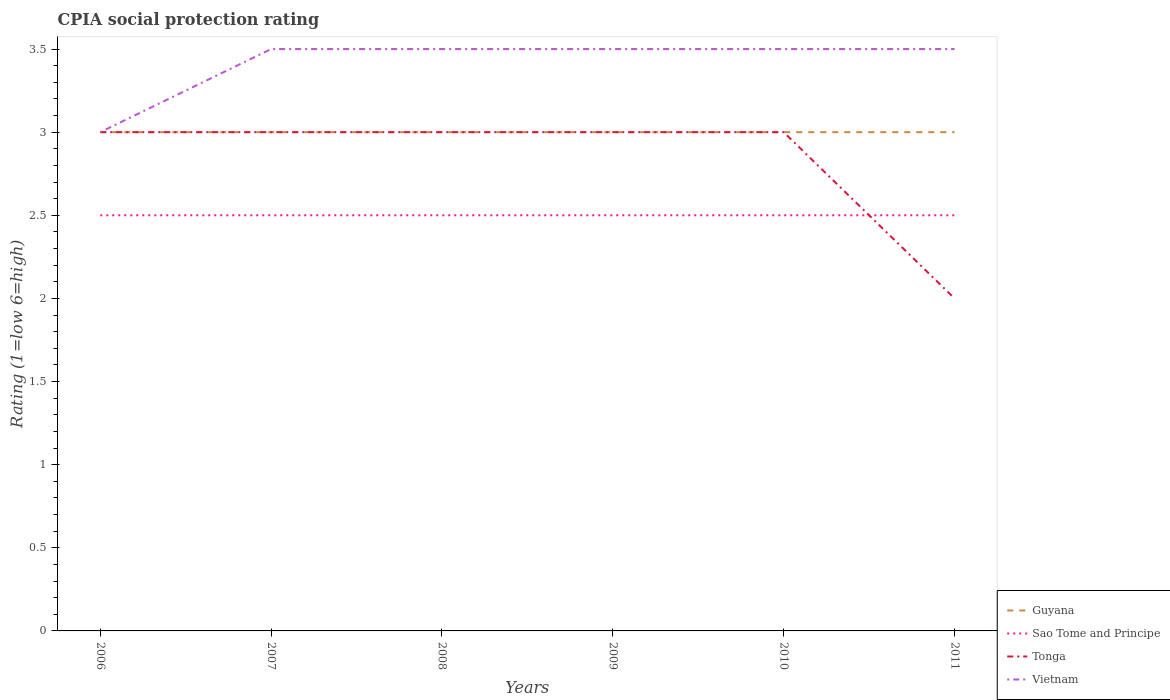Is the number of lines equal to the number of legend labels?
Your response must be concise. Yes. What is the total CPIA rating in Sao Tome and Principe in the graph?
Make the answer very short. 0. What is the difference between the highest and the lowest CPIA rating in Vietnam?
Your answer should be compact. 5. How many years are there in the graph?
Provide a succinct answer. 6. What is the difference between two consecutive major ticks on the Y-axis?
Your response must be concise. 0.5. Are the values on the major ticks of Y-axis written in scientific E-notation?
Ensure brevity in your answer.  No. Does the graph contain any zero values?
Offer a very short reply. No. How many legend labels are there?
Your answer should be compact. 4. How are the legend labels stacked?
Give a very brief answer. Vertical. What is the title of the graph?
Keep it short and to the point. CPIA social protection rating. Does "Mongolia" appear as one of the legend labels in the graph?
Make the answer very short. No. What is the label or title of the X-axis?
Your answer should be compact. Years. What is the label or title of the Y-axis?
Your answer should be very brief. Rating (1=low 6=high). What is the Rating (1=low 6=high) of Guyana in 2006?
Your answer should be very brief. 3. What is the Rating (1=low 6=high) in Tonga in 2006?
Make the answer very short. 3. What is the Rating (1=low 6=high) of Vietnam in 2006?
Provide a succinct answer. 3. What is the Rating (1=low 6=high) of Guyana in 2007?
Offer a terse response. 3. What is the Rating (1=low 6=high) of Guyana in 2008?
Provide a short and direct response. 3. What is the Rating (1=low 6=high) in Sao Tome and Principe in 2008?
Offer a terse response. 2.5. What is the Rating (1=low 6=high) in Tonga in 2008?
Your answer should be very brief. 3. What is the Rating (1=low 6=high) of Vietnam in 2008?
Provide a succinct answer. 3.5. What is the Rating (1=low 6=high) in Guyana in 2009?
Ensure brevity in your answer.  3. What is the Rating (1=low 6=high) of Tonga in 2009?
Make the answer very short. 3. What is the Rating (1=low 6=high) of Vietnam in 2009?
Your answer should be very brief. 3.5. What is the Rating (1=low 6=high) in Sao Tome and Principe in 2010?
Offer a very short reply. 2.5. What is the Rating (1=low 6=high) of Vietnam in 2010?
Your response must be concise. 3.5. What is the Rating (1=low 6=high) in Guyana in 2011?
Your answer should be compact. 3. What is the Rating (1=low 6=high) of Tonga in 2011?
Offer a terse response. 2. What is the Rating (1=low 6=high) of Vietnam in 2011?
Ensure brevity in your answer.  3.5. Across all years, what is the maximum Rating (1=low 6=high) in Guyana?
Your response must be concise. 3. Across all years, what is the maximum Rating (1=low 6=high) in Vietnam?
Your response must be concise. 3.5. Across all years, what is the minimum Rating (1=low 6=high) of Sao Tome and Principe?
Your answer should be very brief. 2.5. Across all years, what is the minimum Rating (1=low 6=high) in Tonga?
Give a very brief answer. 2. What is the total Rating (1=low 6=high) in Sao Tome and Principe in the graph?
Provide a succinct answer. 15. What is the total Rating (1=low 6=high) in Tonga in the graph?
Your answer should be compact. 17. What is the total Rating (1=low 6=high) of Vietnam in the graph?
Give a very brief answer. 20.5. What is the difference between the Rating (1=low 6=high) in Tonga in 2006 and that in 2007?
Your answer should be very brief. 0. What is the difference between the Rating (1=low 6=high) of Tonga in 2006 and that in 2008?
Your answer should be compact. 0. What is the difference between the Rating (1=low 6=high) of Vietnam in 2006 and that in 2008?
Your response must be concise. -0.5. What is the difference between the Rating (1=low 6=high) of Guyana in 2006 and that in 2009?
Provide a short and direct response. 0. What is the difference between the Rating (1=low 6=high) of Tonga in 2006 and that in 2009?
Your answer should be compact. 0. What is the difference between the Rating (1=low 6=high) in Vietnam in 2006 and that in 2009?
Provide a succinct answer. -0.5. What is the difference between the Rating (1=low 6=high) in Guyana in 2006 and that in 2010?
Offer a very short reply. 0. What is the difference between the Rating (1=low 6=high) of Tonga in 2006 and that in 2010?
Provide a succinct answer. 0. What is the difference between the Rating (1=low 6=high) of Tonga in 2006 and that in 2011?
Keep it short and to the point. 1. What is the difference between the Rating (1=low 6=high) of Guyana in 2007 and that in 2008?
Your response must be concise. 0. What is the difference between the Rating (1=low 6=high) in Tonga in 2007 and that in 2008?
Give a very brief answer. 0. What is the difference between the Rating (1=low 6=high) in Vietnam in 2007 and that in 2008?
Give a very brief answer. 0. What is the difference between the Rating (1=low 6=high) in Guyana in 2007 and that in 2009?
Make the answer very short. 0. What is the difference between the Rating (1=low 6=high) of Tonga in 2007 and that in 2009?
Your response must be concise. 0. What is the difference between the Rating (1=low 6=high) in Vietnam in 2007 and that in 2009?
Offer a terse response. 0. What is the difference between the Rating (1=low 6=high) of Guyana in 2007 and that in 2010?
Give a very brief answer. 0. What is the difference between the Rating (1=low 6=high) in Tonga in 2007 and that in 2011?
Make the answer very short. 1. What is the difference between the Rating (1=low 6=high) of Vietnam in 2007 and that in 2011?
Ensure brevity in your answer.  0. What is the difference between the Rating (1=low 6=high) in Sao Tome and Principe in 2008 and that in 2009?
Provide a short and direct response. 0. What is the difference between the Rating (1=low 6=high) of Tonga in 2008 and that in 2009?
Offer a very short reply. 0. What is the difference between the Rating (1=low 6=high) in Vietnam in 2008 and that in 2009?
Make the answer very short. 0. What is the difference between the Rating (1=low 6=high) in Sao Tome and Principe in 2008 and that in 2010?
Provide a succinct answer. 0. What is the difference between the Rating (1=low 6=high) in Tonga in 2008 and that in 2010?
Your answer should be compact. 0. What is the difference between the Rating (1=low 6=high) in Guyana in 2008 and that in 2011?
Your response must be concise. 0. What is the difference between the Rating (1=low 6=high) of Sao Tome and Principe in 2008 and that in 2011?
Make the answer very short. 0. What is the difference between the Rating (1=low 6=high) in Guyana in 2009 and that in 2010?
Your answer should be very brief. 0. What is the difference between the Rating (1=low 6=high) in Sao Tome and Principe in 2009 and that in 2010?
Offer a very short reply. 0. What is the difference between the Rating (1=low 6=high) in Guyana in 2009 and that in 2011?
Provide a short and direct response. 0. What is the difference between the Rating (1=low 6=high) in Sao Tome and Principe in 2009 and that in 2011?
Offer a very short reply. 0. What is the difference between the Rating (1=low 6=high) of Vietnam in 2009 and that in 2011?
Your response must be concise. 0. What is the difference between the Rating (1=low 6=high) of Sao Tome and Principe in 2010 and that in 2011?
Your answer should be very brief. 0. What is the difference between the Rating (1=low 6=high) in Tonga in 2010 and that in 2011?
Provide a succinct answer. 1. What is the difference between the Rating (1=low 6=high) in Vietnam in 2010 and that in 2011?
Keep it short and to the point. 0. What is the difference between the Rating (1=low 6=high) in Guyana in 2006 and the Rating (1=low 6=high) in Sao Tome and Principe in 2007?
Your response must be concise. 0.5. What is the difference between the Rating (1=low 6=high) of Guyana in 2006 and the Rating (1=low 6=high) of Vietnam in 2007?
Your response must be concise. -0.5. What is the difference between the Rating (1=low 6=high) of Sao Tome and Principe in 2006 and the Rating (1=low 6=high) of Tonga in 2007?
Provide a short and direct response. -0.5. What is the difference between the Rating (1=low 6=high) of Sao Tome and Principe in 2006 and the Rating (1=low 6=high) of Vietnam in 2007?
Keep it short and to the point. -1. What is the difference between the Rating (1=low 6=high) in Tonga in 2006 and the Rating (1=low 6=high) in Vietnam in 2007?
Provide a short and direct response. -0.5. What is the difference between the Rating (1=low 6=high) of Guyana in 2006 and the Rating (1=low 6=high) of Sao Tome and Principe in 2008?
Provide a succinct answer. 0.5. What is the difference between the Rating (1=low 6=high) in Guyana in 2006 and the Rating (1=low 6=high) in Tonga in 2008?
Your response must be concise. 0. What is the difference between the Rating (1=low 6=high) in Sao Tome and Principe in 2006 and the Rating (1=low 6=high) in Tonga in 2008?
Give a very brief answer. -0.5. What is the difference between the Rating (1=low 6=high) in Sao Tome and Principe in 2006 and the Rating (1=low 6=high) in Vietnam in 2008?
Your answer should be very brief. -1. What is the difference between the Rating (1=low 6=high) in Guyana in 2006 and the Rating (1=low 6=high) in Sao Tome and Principe in 2009?
Provide a short and direct response. 0.5. What is the difference between the Rating (1=low 6=high) in Sao Tome and Principe in 2006 and the Rating (1=low 6=high) in Vietnam in 2009?
Ensure brevity in your answer.  -1. What is the difference between the Rating (1=low 6=high) in Tonga in 2006 and the Rating (1=low 6=high) in Vietnam in 2009?
Offer a terse response. -0.5. What is the difference between the Rating (1=low 6=high) in Guyana in 2006 and the Rating (1=low 6=high) in Sao Tome and Principe in 2010?
Keep it short and to the point. 0.5. What is the difference between the Rating (1=low 6=high) of Guyana in 2006 and the Rating (1=low 6=high) of Vietnam in 2010?
Your answer should be very brief. -0.5. What is the difference between the Rating (1=low 6=high) of Sao Tome and Principe in 2006 and the Rating (1=low 6=high) of Tonga in 2010?
Offer a terse response. -0.5. What is the difference between the Rating (1=low 6=high) of Sao Tome and Principe in 2006 and the Rating (1=low 6=high) of Vietnam in 2010?
Ensure brevity in your answer.  -1. What is the difference between the Rating (1=low 6=high) in Tonga in 2006 and the Rating (1=low 6=high) in Vietnam in 2010?
Provide a succinct answer. -0.5. What is the difference between the Rating (1=low 6=high) of Guyana in 2006 and the Rating (1=low 6=high) of Sao Tome and Principe in 2011?
Offer a very short reply. 0.5. What is the difference between the Rating (1=low 6=high) of Guyana in 2006 and the Rating (1=low 6=high) of Tonga in 2011?
Your response must be concise. 1. What is the difference between the Rating (1=low 6=high) in Sao Tome and Principe in 2006 and the Rating (1=low 6=high) in Vietnam in 2011?
Offer a terse response. -1. What is the difference between the Rating (1=low 6=high) of Guyana in 2007 and the Rating (1=low 6=high) of Sao Tome and Principe in 2008?
Your answer should be compact. 0.5. What is the difference between the Rating (1=low 6=high) of Guyana in 2007 and the Rating (1=low 6=high) of Vietnam in 2008?
Provide a short and direct response. -0.5. What is the difference between the Rating (1=low 6=high) of Sao Tome and Principe in 2007 and the Rating (1=low 6=high) of Vietnam in 2008?
Provide a short and direct response. -1. What is the difference between the Rating (1=low 6=high) of Tonga in 2007 and the Rating (1=low 6=high) of Vietnam in 2008?
Provide a short and direct response. -0.5. What is the difference between the Rating (1=low 6=high) in Sao Tome and Principe in 2007 and the Rating (1=low 6=high) in Vietnam in 2009?
Provide a succinct answer. -1. What is the difference between the Rating (1=low 6=high) in Guyana in 2007 and the Rating (1=low 6=high) in Vietnam in 2010?
Your answer should be very brief. -0.5. What is the difference between the Rating (1=low 6=high) of Sao Tome and Principe in 2007 and the Rating (1=low 6=high) of Vietnam in 2010?
Ensure brevity in your answer.  -1. What is the difference between the Rating (1=low 6=high) in Tonga in 2007 and the Rating (1=low 6=high) in Vietnam in 2010?
Your response must be concise. -0.5. What is the difference between the Rating (1=low 6=high) in Guyana in 2007 and the Rating (1=low 6=high) in Tonga in 2011?
Your response must be concise. 1. What is the difference between the Rating (1=low 6=high) of Guyana in 2007 and the Rating (1=low 6=high) of Vietnam in 2011?
Offer a terse response. -0.5. What is the difference between the Rating (1=low 6=high) in Sao Tome and Principe in 2007 and the Rating (1=low 6=high) in Tonga in 2011?
Ensure brevity in your answer.  0.5. What is the difference between the Rating (1=low 6=high) in Sao Tome and Principe in 2007 and the Rating (1=low 6=high) in Vietnam in 2011?
Provide a succinct answer. -1. What is the difference between the Rating (1=low 6=high) of Tonga in 2007 and the Rating (1=low 6=high) of Vietnam in 2011?
Make the answer very short. -0.5. What is the difference between the Rating (1=low 6=high) of Guyana in 2008 and the Rating (1=low 6=high) of Tonga in 2009?
Provide a succinct answer. 0. What is the difference between the Rating (1=low 6=high) of Guyana in 2008 and the Rating (1=low 6=high) of Vietnam in 2009?
Offer a terse response. -0.5. What is the difference between the Rating (1=low 6=high) in Sao Tome and Principe in 2008 and the Rating (1=low 6=high) in Tonga in 2009?
Give a very brief answer. -0.5. What is the difference between the Rating (1=low 6=high) in Sao Tome and Principe in 2008 and the Rating (1=low 6=high) in Vietnam in 2009?
Make the answer very short. -1. What is the difference between the Rating (1=low 6=high) of Guyana in 2008 and the Rating (1=low 6=high) of Sao Tome and Principe in 2010?
Provide a short and direct response. 0.5. What is the difference between the Rating (1=low 6=high) in Sao Tome and Principe in 2008 and the Rating (1=low 6=high) in Tonga in 2010?
Your response must be concise. -0.5. What is the difference between the Rating (1=low 6=high) of Tonga in 2008 and the Rating (1=low 6=high) of Vietnam in 2010?
Ensure brevity in your answer.  -0.5. What is the difference between the Rating (1=low 6=high) in Guyana in 2008 and the Rating (1=low 6=high) in Sao Tome and Principe in 2011?
Offer a very short reply. 0.5. What is the difference between the Rating (1=low 6=high) of Guyana in 2008 and the Rating (1=low 6=high) of Tonga in 2011?
Your answer should be compact. 1. What is the difference between the Rating (1=low 6=high) in Guyana in 2008 and the Rating (1=low 6=high) in Vietnam in 2011?
Provide a succinct answer. -0.5. What is the difference between the Rating (1=low 6=high) of Sao Tome and Principe in 2008 and the Rating (1=low 6=high) of Tonga in 2011?
Make the answer very short. 0.5. What is the difference between the Rating (1=low 6=high) of Guyana in 2009 and the Rating (1=low 6=high) of Tonga in 2010?
Provide a short and direct response. 0. What is the difference between the Rating (1=low 6=high) in Tonga in 2009 and the Rating (1=low 6=high) in Vietnam in 2010?
Keep it short and to the point. -0.5. What is the difference between the Rating (1=low 6=high) of Guyana in 2009 and the Rating (1=low 6=high) of Tonga in 2011?
Give a very brief answer. 1. What is the difference between the Rating (1=low 6=high) of Guyana in 2009 and the Rating (1=low 6=high) of Vietnam in 2011?
Keep it short and to the point. -0.5. What is the difference between the Rating (1=low 6=high) in Sao Tome and Principe in 2009 and the Rating (1=low 6=high) in Tonga in 2011?
Provide a succinct answer. 0.5. What is the difference between the Rating (1=low 6=high) in Guyana in 2010 and the Rating (1=low 6=high) in Sao Tome and Principe in 2011?
Give a very brief answer. 0.5. What is the difference between the Rating (1=low 6=high) of Guyana in 2010 and the Rating (1=low 6=high) of Tonga in 2011?
Your response must be concise. 1. What is the difference between the Rating (1=low 6=high) of Guyana in 2010 and the Rating (1=low 6=high) of Vietnam in 2011?
Offer a very short reply. -0.5. What is the average Rating (1=low 6=high) of Tonga per year?
Your response must be concise. 2.83. What is the average Rating (1=low 6=high) of Vietnam per year?
Your answer should be very brief. 3.42. In the year 2006, what is the difference between the Rating (1=low 6=high) in Guyana and Rating (1=low 6=high) in Tonga?
Offer a terse response. 0. In the year 2007, what is the difference between the Rating (1=low 6=high) in Guyana and Rating (1=low 6=high) in Sao Tome and Principe?
Provide a short and direct response. 0.5. In the year 2007, what is the difference between the Rating (1=low 6=high) in Sao Tome and Principe and Rating (1=low 6=high) in Tonga?
Your response must be concise. -0.5. In the year 2007, what is the difference between the Rating (1=low 6=high) of Tonga and Rating (1=low 6=high) of Vietnam?
Offer a terse response. -0.5. In the year 2008, what is the difference between the Rating (1=low 6=high) in Guyana and Rating (1=low 6=high) in Sao Tome and Principe?
Provide a short and direct response. 0.5. In the year 2008, what is the difference between the Rating (1=low 6=high) of Guyana and Rating (1=low 6=high) of Tonga?
Make the answer very short. 0. In the year 2008, what is the difference between the Rating (1=low 6=high) in Guyana and Rating (1=low 6=high) in Vietnam?
Offer a very short reply. -0.5. In the year 2008, what is the difference between the Rating (1=low 6=high) of Tonga and Rating (1=low 6=high) of Vietnam?
Offer a terse response. -0.5. In the year 2009, what is the difference between the Rating (1=low 6=high) in Guyana and Rating (1=low 6=high) in Sao Tome and Principe?
Ensure brevity in your answer.  0.5. In the year 2009, what is the difference between the Rating (1=low 6=high) in Guyana and Rating (1=low 6=high) in Tonga?
Provide a succinct answer. 0. In the year 2009, what is the difference between the Rating (1=low 6=high) in Sao Tome and Principe and Rating (1=low 6=high) in Tonga?
Offer a terse response. -0.5. In the year 2010, what is the difference between the Rating (1=low 6=high) in Guyana and Rating (1=low 6=high) in Sao Tome and Principe?
Offer a terse response. 0.5. In the year 2010, what is the difference between the Rating (1=low 6=high) in Guyana and Rating (1=low 6=high) in Tonga?
Your answer should be very brief. 0. In the year 2010, what is the difference between the Rating (1=low 6=high) of Guyana and Rating (1=low 6=high) of Vietnam?
Offer a terse response. -0.5. In the year 2010, what is the difference between the Rating (1=low 6=high) in Sao Tome and Principe and Rating (1=low 6=high) in Vietnam?
Keep it short and to the point. -1. In the year 2011, what is the difference between the Rating (1=low 6=high) of Guyana and Rating (1=low 6=high) of Sao Tome and Principe?
Make the answer very short. 0.5. In the year 2011, what is the difference between the Rating (1=low 6=high) in Sao Tome and Principe and Rating (1=low 6=high) in Vietnam?
Keep it short and to the point. -1. In the year 2011, what is the difference between the Rating (1=low 6=high) of Tonga and Rating (1=low 6=high) of Vietnam?
Offer a very short reply. -1.5. What is the ratio of the Rating (1=low 6=high) in Guyana in 2006 to that in 2007?
Your response must be concise. 1. What is the ratio of the Rating (1=low 6=high) in Tonga in 2006 to that in 2007?
Keep it short and to the point. 1. What is the ratio of the Rating (1=low 6=high) of Vietnam in 2006 to that in 2007?
Your answer should be compact. 0.86. What is the ratio of the Rating (1=low 6=high) of Guyana in 2006 to that in 2008?
Keep it short and to the point. 1. What is the ratio of the Rating (1=low 6=high) in Sao Tome and Principe in 2006 to that in 2008?
Give a very brief answer. 1. What is the ratio of the Rating (1=low 6=high) in Tonga in 2006 to that in 2008?
Give a very brief answer. 1. What is the ratio of the Rating (1=low 6=high) of Guyana in 2006 to that in 2009?
Your answer should be compact. 1. What is the ratio of the Rating (1=low 6=high) in Vietnam in 2006 to that in 2009?
Provide a short and direct response. 0.86. What is the ratio of the Rating (1=low 6=high) of Guyana in 2006 to that in 2010?
Provide a short and direct response. 1. What is the ratio of the Rating (1=low 6=high) in Sao Tome and Principe in 2006 to that in 2010?
Make the answer very short. 1. What is the ratio of the Rating (1=low 6=high) in Tonga in 2006 to that in 2011?
Make the answer very short. 1.5. What is the ratio of the Rating (1=low 6=high) of Vietnam in 2006 to that in 2011?
Ensure brevity in your answer.  0.86. What is the ratio of the Rating (1=low 6=high) of Sao Tome and Principe in 2007 to that in 2008?
Provide a short and direct response. 1. What is the ratio of the Rating (1=low 6=high) in Tonga in 2007 to that in 2008?
Provide a short and direct response. 1. What is the ratio of the Rating (1=low 6=high) of Vietnam in 2007 to that in 2008?
Provide a short and direct response. 1. What is the ratio of the Rating (1=low 6=high) of Guyana in 2007 to that in 2009?
Keep it short and to the point. 1. What is the ratio of the Rating (1=low 6=high) of Sao Tome and Principe in 2007 to that in 2009?
Provide a short and direct response. 1. What is the ratio of the Rating (1=low 6=high) of Tonga in 2007 to that in 2009?
Your answer should be compact. 1. What is the ratio of the Rating (1=low 6=high) of Sao Tome and Principe in 2007 to that in 2011?
Give a very brief answer. 1. What is the ratio of the Rating (1=low 6=high) of Tonga in 2007 to that in 2011?
Make the answer very short. 1.5. What is the ratio of the Rating (1=low 6=high) in Sao Tome and Principe in 2008 to that in 2009?
Ensure brevity in your answer.  1. What is the ratio of the Rating (1=low 6=high) in Sao Tome and Principe in 2008 to that in 2010?
Ensure brevity in your answer.  1. What is the ratio of the Rating (1=low 6=high) in Vietnam in 2008 to that in 2010?
Give a very brief answer. 1. What is the ratio of the Rating (1=low 6=high) in Guyana in 2008 to that in 2011?
Make the answer very short. 1. What is the ratio of the Rating (1=low 6=high) in Sao Tome and Principe in 2008 to that in 2011?
Provide a short and direct response. 1. What is the ratio of the Rating (1=low 6=high) in Tonga in 2008 to that in 2011?
Your response must be concise. 1.5. What is the ratio of the Rating (1=low 6=high) of Guyana in 2009 to that in 2010?
Give a very brief answer. 1. What is the ratio of the Rating (1=low 6=high) in Sao Tome and Principe in 2009 to that in 2010?
Ensure brevity in your answer.  1. What is the ratio of the Rating (1=low 6=high) of Tonga in 2009 to that in 2010?
Keep it short and to the point. 1. What is the ratio of the Rating (1=low 6=high) in Guyana in 2009 to that in 2011?
Provide a succinct answer. 1. What is the ratio of the Rating (1=low 6=high) in Vietnam in 2009 to that in 2011?
Your response must be concise. 1. What is the difference between the highest and the second highest Rating (1=low 6=high) in Sao Tome and Principe?
Provide a short and direct response. 0. What is the difference between the highest and the second highest Rating (1=low 6=high) in Tonga?
Provide a short and direct response. 0. What is the difference between the highest and the second highest Rating (1=low 6=high) of Vietnam?
Your answer should be compact. 0. What is the difference between the highest and the lowest Rating (1=low 6=high) of Guyana?
Your response must be concise. 0. What is the difference between the highest and the lowest Rating (1=low 6=high) in Vietnam?
Offer a very short reply. 0.5. 